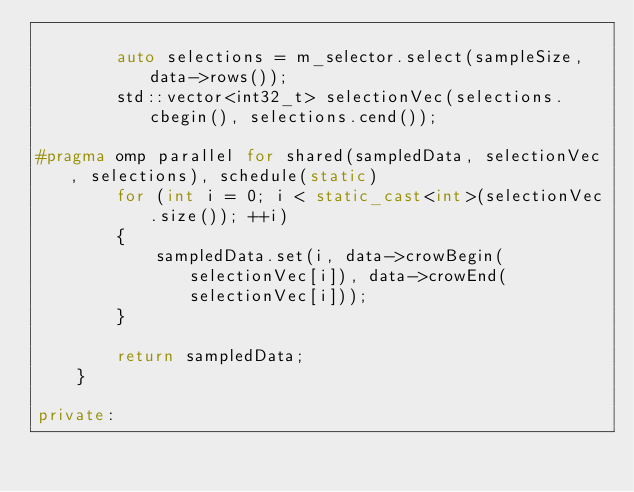<code> <loc_0><loc_0><loc_500><loc_500><_C++_>
        auto selections = m_selector.select(sampleSize, data->rows());
        std::vector<int32_t> selectionVec(selections.cbegin(), selections.cend());

#pragma omp parallel for shared(sampledData, selectionVec, selections), schedule(static)
        for (int i = 0; i < static_cast<int>(selectionVec.size()); ++i)
        {
            sampledData.set(i, data->crowBegin(selectionVec[i]), data->crowEnd(selectionVec[i]));
        }

        return sampledData;
    }

private:</code> 